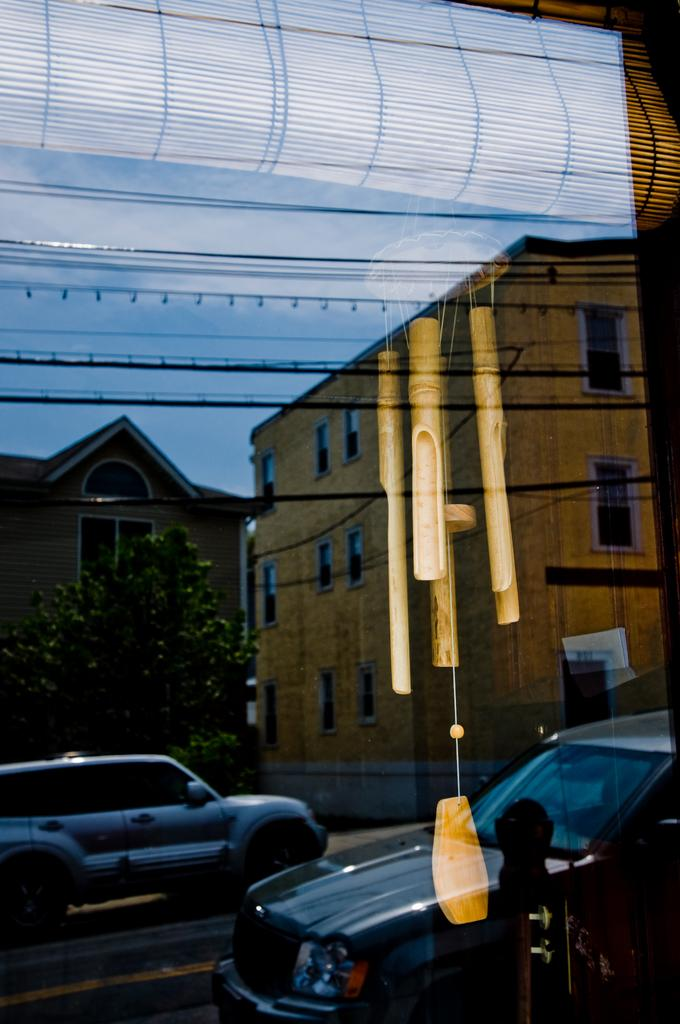What type of vehicles can be seen on the road in the image? There are cars on the road in the image. What natural element is visible in the image? There is a tree visible in the image. What type of structures can be seen in the background of the image? There are buildings in the background of the image. What architectural feature is visible in the image? There is a window visible in the image. What part of the natural environment is visible in the image? The sky is visible in the image. What type of treatment is being administered to the tree in the image? There is no treatment being administered to the tree in the image; it is simply a tree visible in the background. What type of hat is the car wearing in the image? Cars do not wear hats, as they are inanimate objects. 